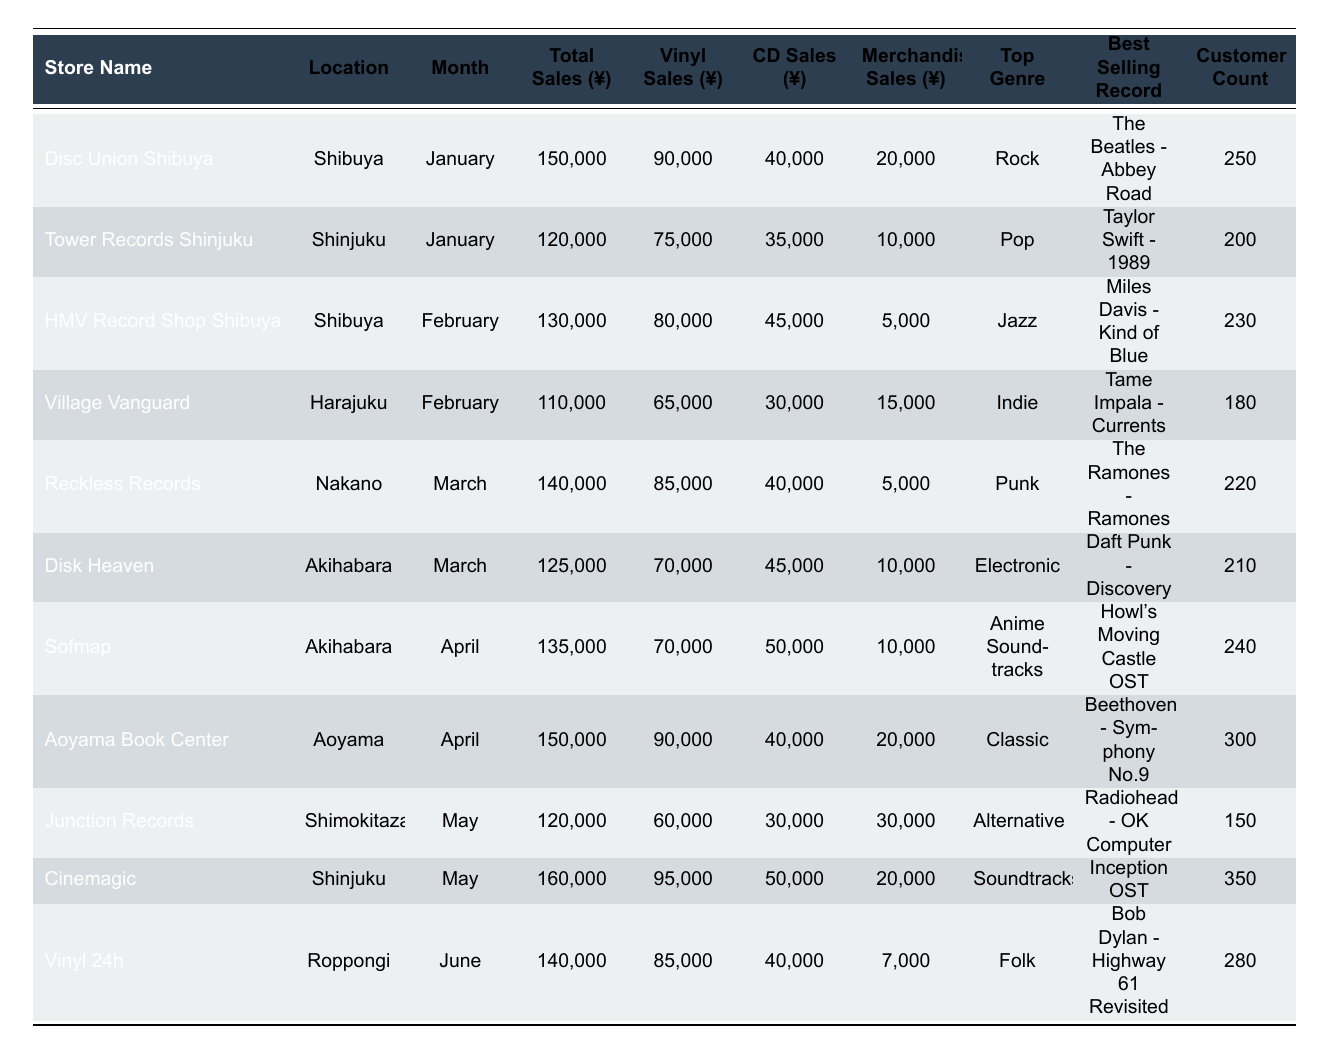What is the best-selling record at Tower Records Shinjuku in January? The table shows that Tower Records Shinjuku’s best-selling record for January is "Taylor Swift - 1989."
Answer: Taylor Swift - 1989 Which store had the highest total sales in May? According to the data, Cinemagic in Shinjuku had the highest total sales in May, amounting to ¥160,000.
Answer: Cinemagic How many customers visited Aoyama Book Center in April? The table indicates that Aoyama Book Center had a customer count of 300 in April.
Answer: 300 What type of merchandise sales did HMV Record Shop Shibuya have in February? HMV Record Shop Shibuya had merchandise sales of ¥5,000 in February, as shown in the table.
Answer: ¥5,000 Which store sold more vinyl records in January, Disc Union Shibuya or Tower Records Shinjuku? The vinyl sales at Disc Union Shibuya were ¥90,000 while Tower Records Shinjuku had vinyl sales of ¥75,000. Therefore, Disc Union Shibuya sold more vinyl records in January.
Answer: Disc Union Shibuya What was the average total sales of all record stores in March? The total sales for March were ¥140,000 (Reckless Records) + ¥125,000 (Disk Heaven) = ¥265,000. Dividing this by 2 gives an average total sales of ¥132,500.
Answer: ¥132,500 Which store had the least vinyl sales in February? The vinyl sales in February were ¥80,000 for HMV Record Shop Shibuya and ¥65,000 for Village Vanguard. Thus, Village Vanguard had the least vinyl sales.
Answer: Village Vanguard In which month did Vinyl 24h have sales of ¥140,000? The table shows that Vinyl 24h had total sales of ¥140,000 in June.
Answer: June What percentage of total sales were merchandise sales at Cinemagic in May? Cinemagic's merchandise sales were ¥20,000 out of total sales of ¥160,000. Therefore, \( \frac{20,000}{160,000} \times 100 = 12.5\% \).
Answer: 12.5% Did any store have a higher customer count than 350? No, the highest customer count shown in the table is 350 for Cinemagic, meaning no store had a higher customer count.
Answer: No 